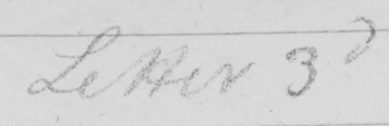What does this handwritten line say? Letter 3d 